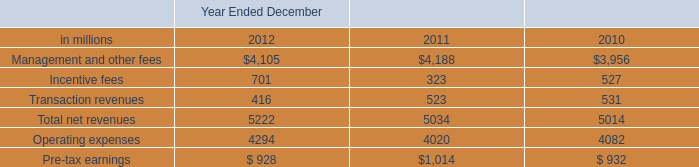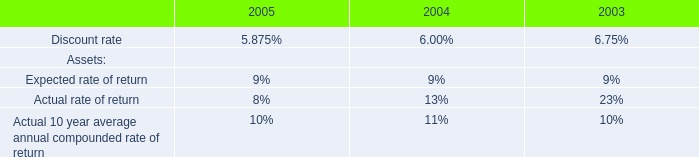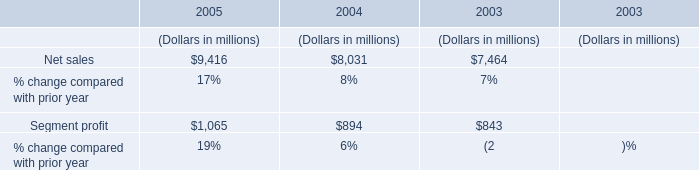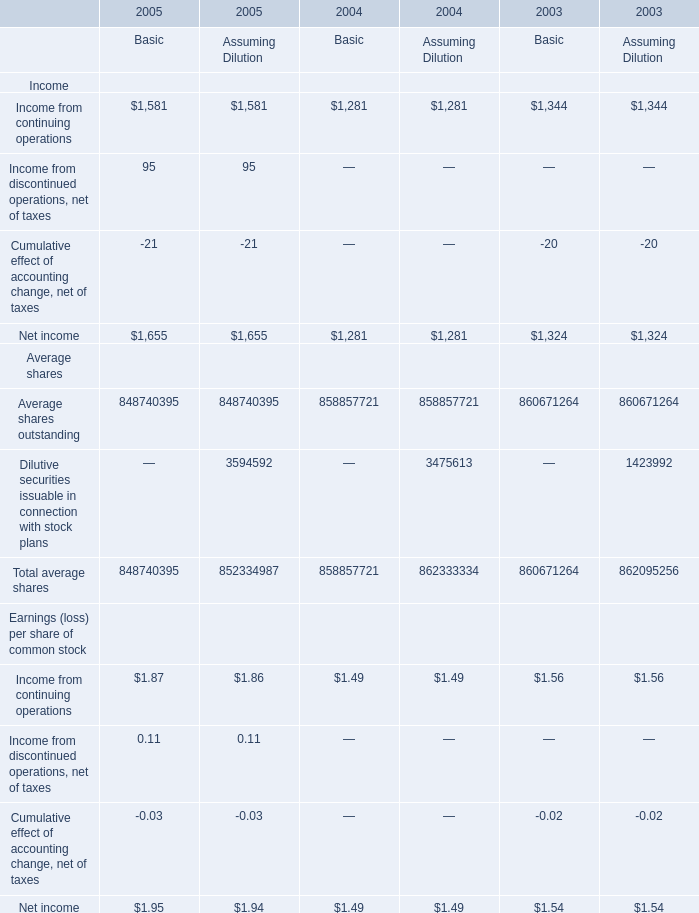What was the total amount of Basic greater than 100 in 2005 ? 
Computations: (1655 + 848740395)
Answer: 848742050.0. 